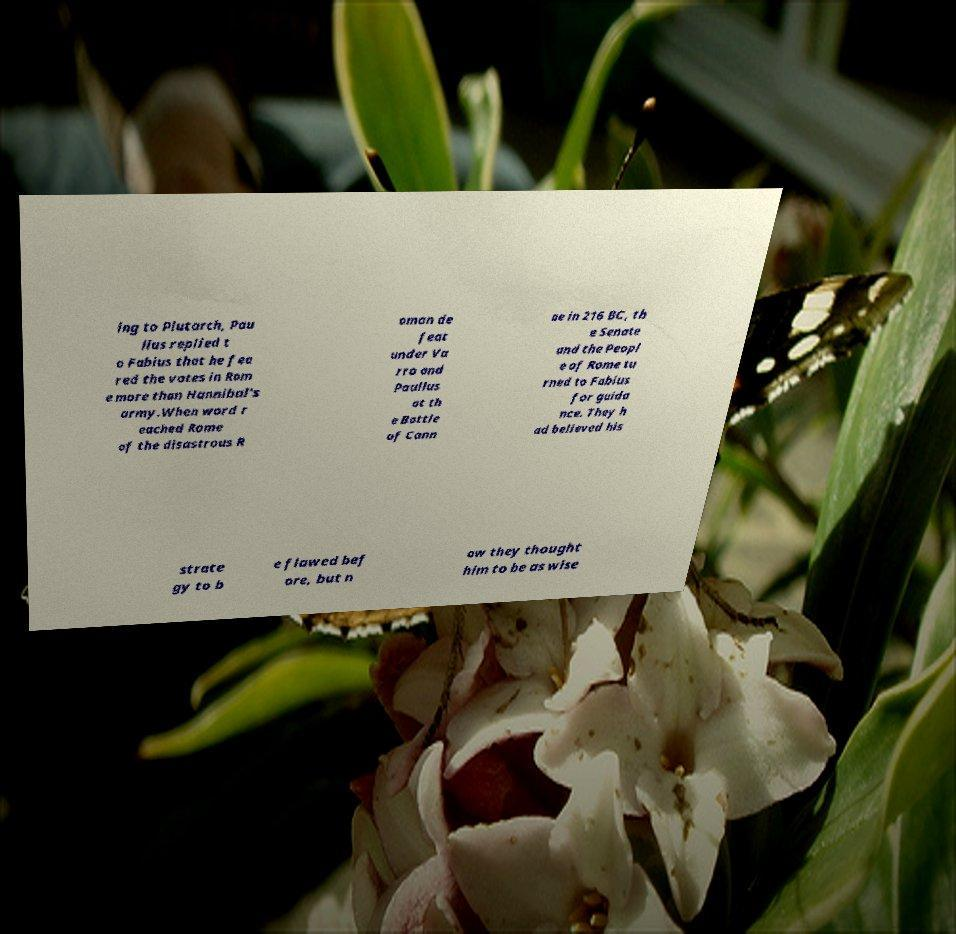For documentation purposes, I need the text within this image transcribed. Could you provide that? ing to Plutarch, Pau llus replied t o Fabius that he fea red the votes in Rom e more than Hannibal's army.When word r eached Rome of the disastrous R oman de feat under Va rro and Paullus at th e Battle of Cann ae in 216 BC, th e Senate and the Peopl e of Rome tu rned to Fabius for guida nce. They h ad believed his strate gy to b e flawed bef ore, but n ow they thought him to be as wise 